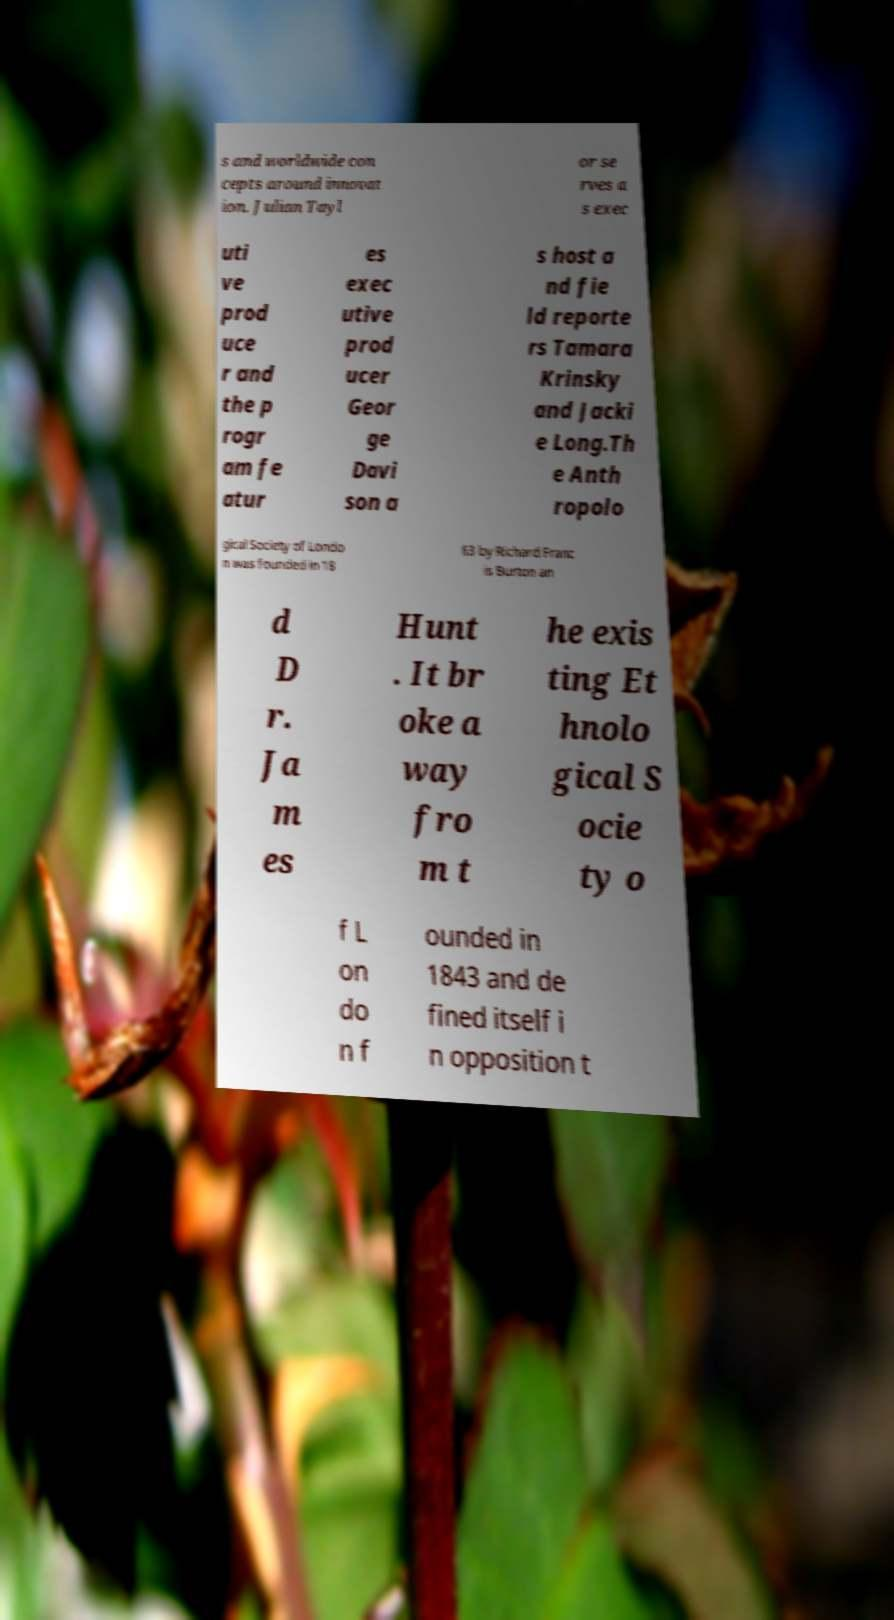Please identify and transcribe the text found in this image. s and worldwide con cepts around innovat ion. Julian Tayl or se rves a s exec uti ve prod uce r and the p rogr am fe atur es exec utive prod ucer Geor ge Davi son a s host a nd fie ld reporte rs Tamara Krinsky and Jacki e Long.Th e Anth ropolo gical Society of Londo n was founded in 18 63 by Richard Franc is Burton an d D r. Ja m es Hunt . It br oke a way fro m t he exis ting Et hnolo gical S ocie ty o f L on do n f ounded in 1843 and de fined itself i n opposition t 